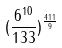Convert formula to latex. <formula><loc_0><loc_0><loc_500><loc_500>( \frac { 6 ^ { 1 0 } } { 1 3 3 } ) ^ { \frac { 4 1 1 } { 9 } }</formula> 